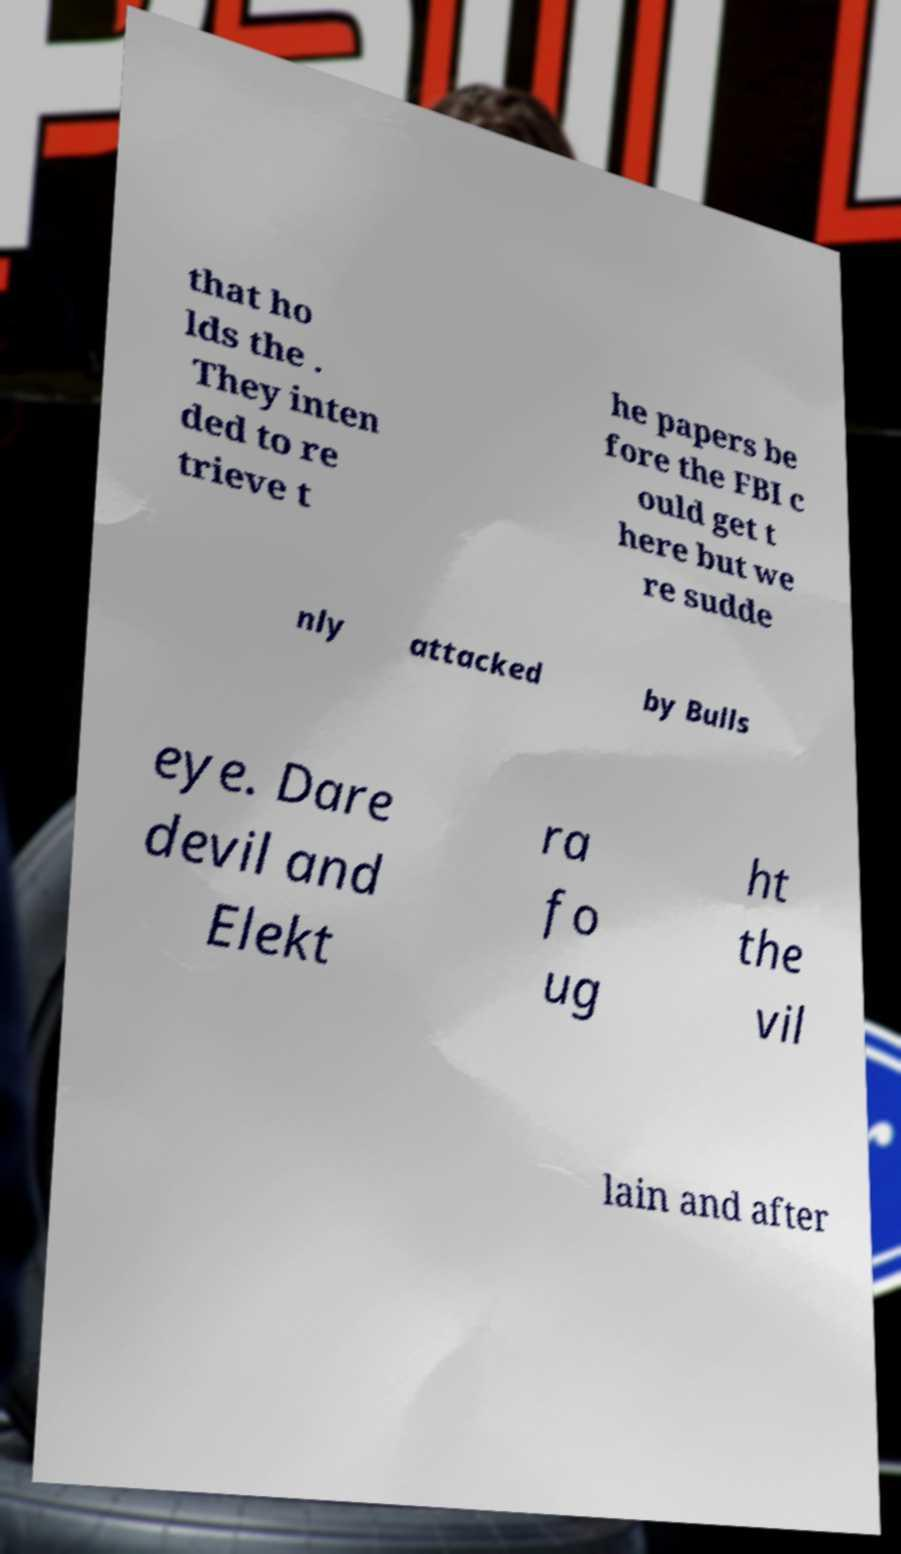Please identify and transcribe the text found in this image. that ho lds the . They inten ded to re trieve t he papers be fore the FBI c ould get t here but we re sudde nly attacked by Bulls eye. Dare devil and Elekt ra fo ug ht the vil lain and after 